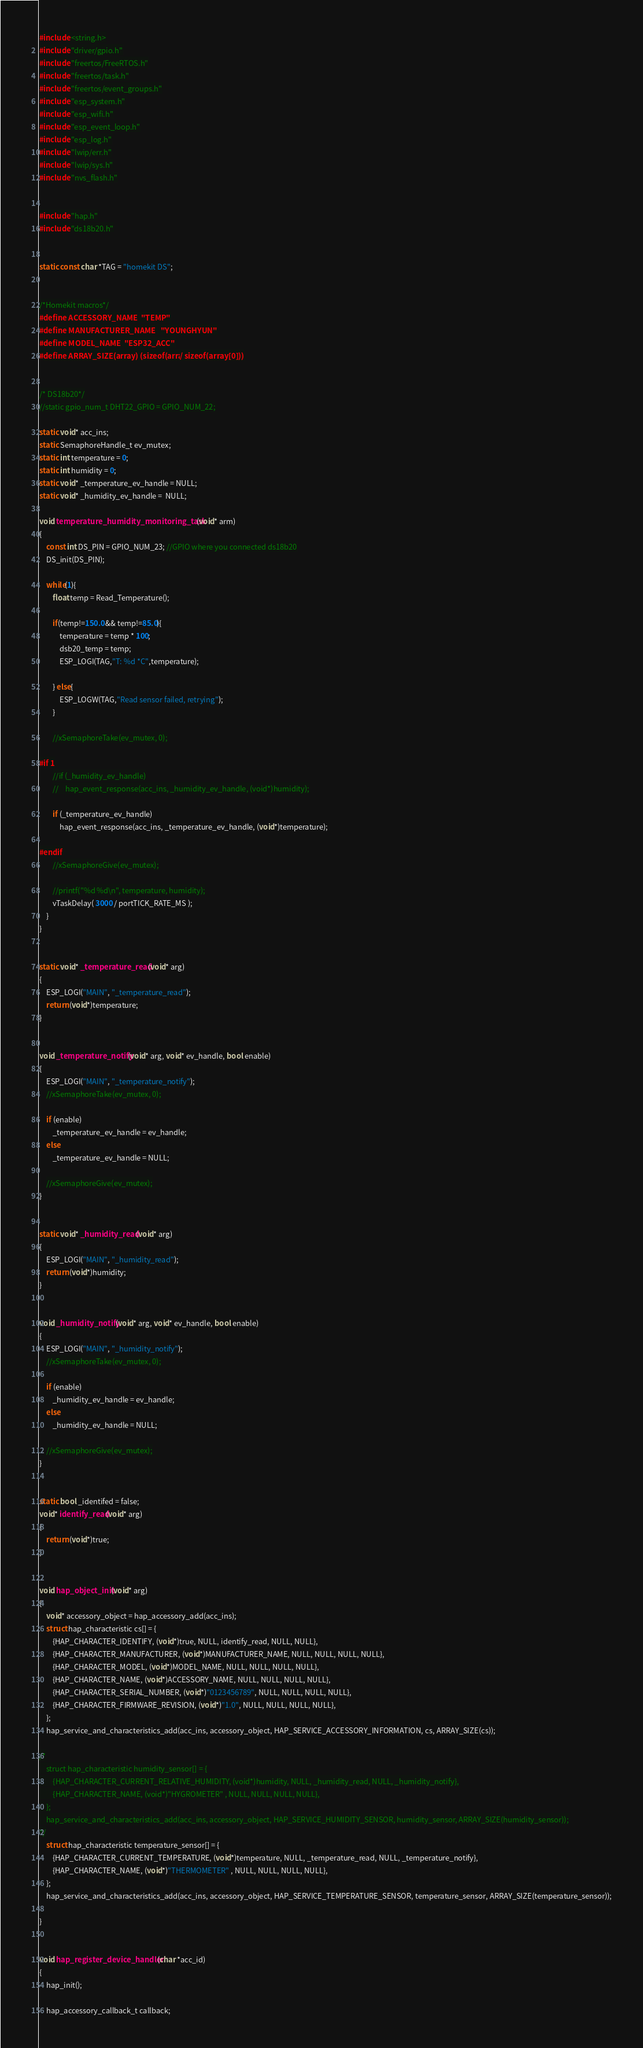Convert code to text. <code><loc_0><loc_0><loc_500><loc_500><_C_>#include <string.h>
#include "driver/gpio.h"
#include "freertos/FreeRTOS.h"
#include "freertos/task.h"
#include "freertos/event_groups.h"
#include "esp_system.h"
#include "esp_wifi.h"
#include "esp_event_loop.h"
#include "esp_log.h"
#include "lwip/err.h"
#include "lwip/sys.h"
#include "nvs_flash.h"


#include "hap.h"
#include "ds18b20.h"


static const char *TAG = "homekit DS";


/*Homekit macros*/
#define ACCESSORY_NAME  "TEMP"
#define MANUFACTURER_NAME   "YOUNGHYUN"
#define MODEL_NAME  "ESP32_ACC"
#define ARRAY_SIZE(array) (sizeof(array) / sizeof(array[0]))


/* DS18b20*/
//static gpio_num_t DHT22_GPIO = GPIO_NUM_22;

static void* acc_ins;
static SemaphoreHandle_t ev_mutex;
static int temperature = 0;
static int humidity = 0;
static void* _temperature_ev_handle = NULL;
static void* _humidity_ev_handle =  NULL;

void temperature_humidity_monitoring_task(void* arm)
{
    const int DS_PIN = GPIO_NUM_23; //GPIO where you connected ds18b20
    DS_init(DS_PIN);

    while(1){
        float temp = Read_Temperature();

        if(temp!=150.0 && temp!=85.0){
            temperature = temp * 100;
            dsb20_temp = temp;
            ESP_LOGI(TAG,"T: %d *C",temperature);

        } else{
            ESP_LOGW(TAG,"Read sensor failed, retrying");
        }

        //xSemaphoreTake(ev_mutex, 0);

#if 1
        //if (_humidity_ev_handle)
        //    hap_event_response(acc_ins, _humidity_ev_handle, (void*)humidity);

        if (_temperature_ev_handle)
            hap_event_response(acc_ins, _temperature_ev_handle, (void*)temperature);

#endif
        //xSemaphoreGive(ev_mutex);

        //printf("%d %d\n", temperature, humidity);
        vTaskDelay( 3000 / portTICK_RATE_MS );
    }
}


static void* _temperature_read(void* arg)
{
    ESP_LOGI("MAIN", "_temperature_read");
    return (void*)temperature;
}


void _temperature_notify(void* arg, void* ev_handle, bool enable)
{
    ESP_LOGI("MAIN", "_temperature_notify");
    //xSemaphoreTake(ev_mutex, 0);

    if (enable) 
        _temperature_ev_handle = ev_handle;
    else 
        _temperature_ev_handle = NULL;

    //xSemaphoreGive(ev_mutex);
}


static void* _humidity_read(void* arg)
{
    ESP_LOGI("MAIN", "_humidity_read");
    return (void*)humidity;
}


void _humidity_notify(void* arg, void* ev_handle, bool enable)
{
    ESP_LOGI("MAIN", "_humidity_notify");
    //xSemaphoreTake(ev_mutex, 0);

    if (enable) 
        _humidity_ev_handle = ev_handle;
    else 
        _humidity_ev_handle = NULL;

    //xSemaphoreGive(ev_mutex);
}


static bool _identifed = false;
void* identify_read(void* arg)
{
    return (void*)true;
}


void hap_object_init(void* arg)
{
    void* accessory_object = hap_accessory_add(acc_ins);
    struct hap_characteristic cs[] = {
        {HAP_CHARACTER_IDENTIFY, (void*)true, NULL, identify_read, NULL, NULL},
        {HAP_CHARACTER_MANUFACTURER, (void*)MANUFACTURER_NAME, NULL, NULL, NULL, NULL},
        {HAP_CHARACTER_MODEL, (void*)MODEL_NAME, NULL, NULL, NULL, NULL},
        {HAP_CHARACTER_NAME, (void*)ACCESSORY_NAME, NULL, NULL, NULL, NULL},
        {HAP_CHARACTER_SERIAL_NUMBER, (void*)"0123456789", NULL, NULL, NULL, NULL},
        {HAP_CHARACTER_FIRMWARE_REVISION, (void*)"1.0", NULL, NULL, NULL, NULL},
    };
    hap_service_and_characteristics_add(acc_ins, accessory_object, HAP_SERVICE_ACCESSORY_INFORMATION, cs, ARRAY_SIZE(cs));

/*
    struct hap_characteristic humidity_sensor[] = {
        {HAP_CHARACTER_CURRENT_RELATIVE_HUMIDITY, (void*)humidity, NULL, _humidity_read, NULL, _humidity_notify},
        {HAP_CHARACTER_NAME, (void*)"HYGROMETER" , NULL, NULL, NULL, NULL},
    };
    hap_service_and_characteristics_add(acc_ins, accessory_object, HAP_SERVICE_HUMIDITY_SENSOR, humidity_sensor, ARRAY_SIZE(humidity_sensor));
*/
    struct hap_characteristic temperature_sensor[] = {
        {HAP_CHARACTER_CURRENT_TEMPERATURE, (void*)temperature, NULL, _temperature_read, NULL, _temperature_notify},
        {HAP_CHARACTER_NAME, (void*)"THERMOMETER" , NULL, NULL, NULL, NULL},
    };
    hap_service_and_characteristics_add(acc_ins, accessory_object, HAP_SERVICE_TEMPERATURE_SENSOR, temperature_sensor, ARRAY_SIZE(temperature_sensor));

}


void hap_register_device_handler(char *acc_id)
{
    hap_init();

    hap_accessory_callback_t callback;</code> 